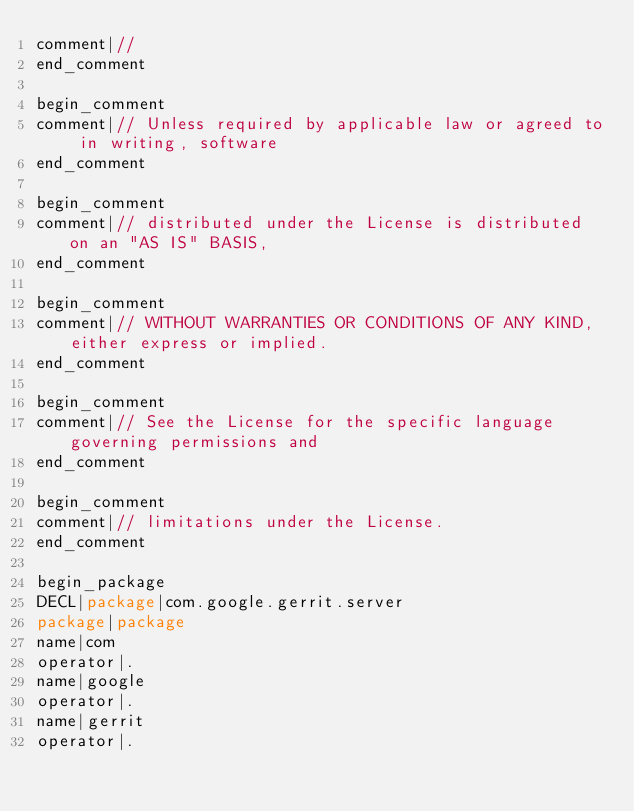<code> <loc_0><loc_0><loc_500><loc_500><_Java_>comment|//
end_comment

begin_comment
comment|// Unless required by applicable law or agreed to in writing, software
end_comment

begin_comment
comment|// distributed under the License is distributed on an "AS IS" BASIS,
end_comment

begin_comment
comment|// WITHOUT WARRANTIES OR CONDITIONS OF ANY KIND, either express or implied.
end_comment

begin_comment
comment|// See the License for the specific language governing permissions and
end_comment

begin_comment
comment|// limitations under the License.
end_comment

begin_package
DECL|package|com.google.gerrit.server
package|package
name|com
operator|.
name|google
operator|.
name|gerrit
operator|.</code> 